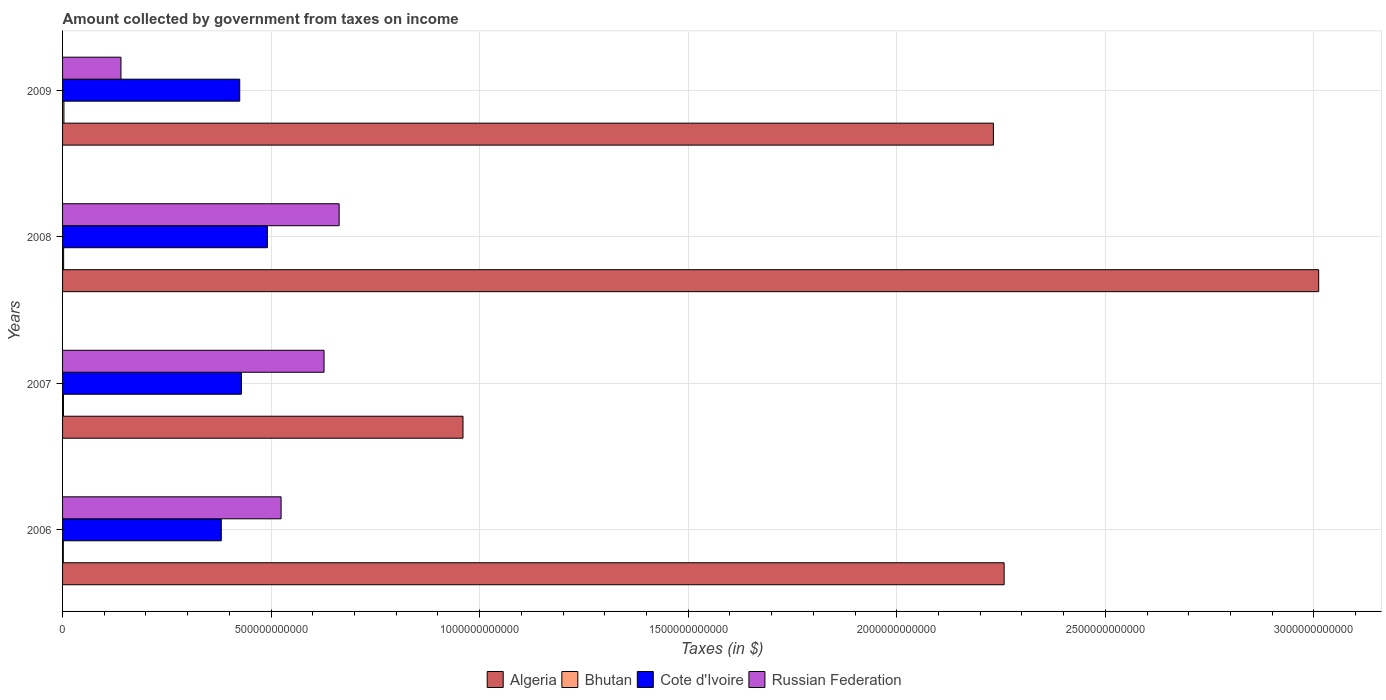Are the number of bars per tick equal to the number of legend labels?
Keep it short and to the point. Yes. How many bars are there on the 1st tick from the top?
Keep it short and to the point. 4. How many bars are there on the 4th tick from the bottom?
Your answer should be very brief. 4. What is the label of the 4th group of bars from the top?
Ensure brevity in your answer.  2006. In how many cases, is the number of bars for a given year not equal to the number of legend labels?
Give a very brief answer. 0. What is the amount collected by government from taxes on income in Bhutan in 2006?
Ensure brevity in your answer.  1.83e+09. Across all years, what is the maximum amount collected by government from taxes on income in Bhutan?
Your response must be concise. 3.28e+09. Across all years, what is the minimum amount collected by government from taxes on income in Algeria?
Provide a succinct answer. 9.60e+11. In which year was the amount collected by government from taxes on income in Bhutan maximum?
Give a very brief answer. 2009. What is the total amount collected by government from taxes on income in Cote d'Ivoire in the graph?
Provide a short and direct response. 1.73e+12. What is the difference between the amount collected by government from taxes on income in Cote d'Ivoire in 2006 and that in 2009?
Give a very brief answer. -4.42e+1. What is the difference between the amount collected by government from taxes on income in Russian Federation in 2009 and the amount collected by government from taxes on income in Bhutan in 2007?
Provide a succinct answer. 1.38e+11. What is the average amount collected by government from taxes on income in Algeria per year?
Offer a very short reply. 2.12e+12. In the year 2009, what is the difference between the amount collected by government from taxes on income in Algeria and amount collected by government from taxes on income in Cote d'Ivoire?
Offer a terse response. 1.81e+12. In how many years, is the amount collected by government from taxes on income in Russian Federation greater than 1700000000000 $?
Your answer should be compact. 0. What is the ratio of the amount collected by government from taxes on income in Algeria in 2006 to that in 2007?
Make the answer very short. 2.35. Is the difference between the amount collected by government from taxes on income in Algeria in 2006 and 2009 greater than the difference between the amount collected by government from taxes on income in Cote d'Ivoire in 2006 and 2009?
Your answer should be very brief. Yes. What is the difference between the highest and the second highest amount collected by government from taxes on income in Algeria?
Provide a succinct answer. 7.54e+11. What is the difference between the highest and the lowest amount collected by government from taxes on income in Cote d'Ivoire?
Your answer should be compact. 1.10e+11. What does the 3rd bar from the top in 2006 represents?
Provide a short and direct response. Bhutan. What does the 2nd bar from the bottom in 2009 represents?
Offer a terse response. Bhutan. Is it the case that in every year, the sum of the amount collected by government from taxes on income in Bhutan and amount collected by government from taxes on income in Russian Federation is greater than the amount collected by government from taxes on income in Algeria?
Offer a terse response. No. Are all the bars in the graph horizontal?
Your answer should be compact. Yes. What is the difference between two consecutive major ticks on the X-axis?
Offer a terse response. 5.00e+11. What is the title of the graph?
Ensure brevity in your answer.  Amount collected by government from taxes on income. Does "Channel Islands" appear as one of the legend labels in the graph?
Your answer should be very brief. No. What is the label or title of the X-axis?
Your answer should be very brief. Taxes (in $). What is the label or title of the Y-axis?
Provide a succinct answer. Years. What is the Taxes (in $) of Algeria in 2006?
Your answer should be compact. 2.26e+12. What is the Taxes (in $) in Bhutan in 2006?
Provide a short and direct response. 1.83e+09. What is the Taxes (in $) of Cote d'Ivoire in 2006?
Keep it short and to the point. 3.81e+11. What is the Taxes (in $) of Russian Federation in 2006?
Offer a very short reply. 5.24e+11. What is the Taxes (in $) of Algeria in 2007?
Keep it short and to the point. 9.60e+11. What is the Taxes (in $) in Bhutan in 2007?
Your answer should be compact. 2.11e+09. What is the Taxes (in $) of Cote d'Ivoire in 2007?
Give a very brief answer. 4.29e+11. What is the Taxes (in $) in Russian Federation in 2007?
Offer a very short reply. 6.27e+11. What is the Taxes (in $) of Algeria in 2008?
Make the answer very short. 3.01e+12. What is the Taxes (in $) in Bhutan in 2008?
Ensure brevity in your answer.  2.55e+09. What is the Taxes (in $) of Cote d'Ivoire in 2008?
Give a very brief answer. 4.91e+11. What is the Taxes (in $) of Russian Federation in 2008?
Your response must be concise. 6.63e+11. What is the Taxes (in $) in Algeria in 2009?
Offer a very short reply. 2.23e+12. What is the Taxes (in $) in Bhutan in 2009?
Give a very brief answer. 3.28e+09. What is the Taxes (in $) in Cote d'Ivoire in 2009?
Give a very brief answer. 4.25e+11. What is the Taxes (in $) in Russian Federation in 2009?
Your answer should be very brief. 1.40e+11. Across all years, what is the maximum Taxes (in $) in Algeria?
Give a very brief answer. 3.01e+12. Across all years, what is the maximum Taxes (in $) in Bhutan?
Your answer should be compact. 3.28e+09. Across all years, what is the maximum Taxes (in $) of Cote d'Ivoire?
Keep it short and to the point. 4.91e+11. Across all years, what is the maximum Taxes (in $) of Russian Federation?
Provide a succinct answer. 6.63e+11. Across all years, what is the minimum Taxes (in $) in Algeria?
Offer a very short reply. 9.60e+11. Across all years, what is the minimum Taxes (in $) of Bhutan?
Make the answer very short. 1.83e+09. Across all years, what is the minimum Taxes (in $) in Cote d'Ivoire?
Offer a terse response. 3.81e+11. Across all years, what is the minimum Taxes (in $) of Russian Federation?
Keep it short and to the point. 1.40e+11. What is the total Taxes (in $) of Algeria in the graph?
Give a very brief answer. 8.46e+12. What is the total Taxes (in $) in Bhutan in the graph?
Provide a succinct answer. 9.77e+09. What is the total Taxes (in $) in Cote d'Ivoire in the graph?
Provide a short and direct response. 1.73e+12. What is the total Taxes (in $) of Russian Federation in the graph?
Keep it short and to the point. 1.95e+12. What is the difference between the Taxes (in $) in Algeria in 2006 and that in 2007?
Keep it short and to the point. 1.30e+12. What is the difference between the Taxes (in $) in Bhutan in 2006 and that in 2007?
Your answer should be compact. -2.76e+08. What is the difference between the Taxes (in $) in Cote d'Ivoire in 2006 and that in 2007?
Provide a succinct answer. -4.83e+1. What is the difference between the Taxes (in $) in Russian Federation in 2006 and that in 2007?
Keep it short and to the point. -1.03e+11. What is the difference between the Taxes (in $) in Algeria in 2006 and that in 2008?
Provide a succinct answer. -7.54e+11. What is the difference between the Taxes (in $) of Bhutan in 2006 and that in 2008?
Your answer should be very brief. -7.14e+08. What is the difference between the Taxes (in $) of Cote d'Ivoire in 2006 and that in 2008?
Give a very brief answer. -1.10e+11. What is the difference between the Taxes (in $) of Russian Federation in 2006 and that in 2008?
Offer a very short reply. -1.39e+11. What is the difference between the Taxes (in $) in Algeria in 2006 and that in 2009?
Offer a very short reply. 2.57e+1. What is the difference between the Taxes (in $) of Bhutan in 2006 and that in 2009?
Provide a succinct answer. -1.45e+09. What is the difference between the Taxes (in $) in Cote d'Ivoire in 2006 and that in 2009?
Keep it short and to the point. -4.42e+1. What is the difference between the Taxes (in $) of Russian Federation in 2006 and that in 2009?
Ensure brevity in your answer.  3.84e+11. What is the difference between the Taxes (in $) of Algeria in 2007 and that in 2008?
Make the answer very short. -2.05e+12. What is the difference between the Taxes (in $) of Bhutan in 2007 and that in 2008?
Give a very brief answer. -4.38e+08. What is the difference between the Taxes (in $) in Cote d'Ivoire in 2007 and that in 2008?
Your answer should be compact. -6.22e+1. What is the difference between the Taxes (in $) in Russian Federation in 2007 and that in 2008?
Your response must be concise. -3.62e+1. What is the difference between the Taxes (in $) of Algeria in 2007 and that in 2009?
Provide a succinct answer. -1.27e+12. What is the difference between the Taxes (in $) in Bhutan in 2007 and that in 2009?
Provide a short and direct response. -1.17e+09. What is the difference between the Taxes (in $) in Cote d'Ivoire in 2007 and that in 2009?
Offer a terse response. 4.06e+09. What is the difference between the Taxes (in $) of Russian Federation in 2007 and that in 2009?
Your answer should be very brief. 4.87e+11. What is the difference between the Taxes (in $) of Algeria in 2008 and that in 2009?
Your answer should be compact. 7.80e+11. What is the difference between the Taxes (in $) in Bhutan in 2008 and that in 2009?
Give a very brief answer. -7.35e+08. What is the difference between the Taxes (in $) of Cote d'Ivoire in 2008 and that in 2009?
Make the answer very short. 6.63e+1. What is the difference between the Taxes (in $) of Russian Federation in 2008 and that in 2009?
Ensure brevity in your answer.  5.23e+11. What is the difference between the Taxes (in $) of Algeria in 2006 and the Taxes (in $) of Bhutan in 2007?
Provide a succinct answer. 2.26e+12. What is the difference between the Taxes (in $) in Algeria in 2006 and the Taxes (in $) in Cote d'Ivoire in 2007?
Offer a very short reply. 1.83e+12. What is the difference between the Taxes (in $) in Algeria in 2006 and the Taxes (in $) in Russian Federation in 2007?
Offer a terse response. 1.63e+12. What is the difference between the Taxes (in $) in Bhutan in 2006 and the Taxes (in $) in Cote d'Ivoire in 2007?
Ensure brevity in your answer.  -4.27e+11. What is the difference between the Taxes (in $) in Bhutan in 2006 and the Taxes (in $) in Russian Federation in 2007?
Provide a short and direct response. -6.25e+11. What is the difference between the Taxes (in $) in Cote d'Ivoire in 2006 and the Taxes (in $) in Russian Federation in 2007?
Keep it short and to the point. -2.46e+11. What is the difference between the Taxes (in $) in Algeria in 2006 and the Taxes (in $) in Bhutan in 2008?
Give a very brief answer. 2.25e+12. What is the difference between the Taxes (in $) in Algeria in 2006 and the Taxes (in $) in Cote d'Ivoire in 2008?
Ensure brevity in your answer.  1.77e+12. What is the difference between the Taxes (in $) of Algeria in 2006 and the Taxes (in $) of Russian Federation in 2008?
Keep it short and to the point. 1.59e+12. What is the difference between the Taxes (in $) in Bhutan in 2006 and the Taxes (in $) in Cote d'Ivoire in 2008?
Provide a succinct answer. -4.89e+11. What is the difference between the Taxes (in $) in Bhutan in 2006 and the Taxes (in $) in Russian Federation in 2008?
Your answer should be compact. -6.61e+11. What is the difference between the Taxes (in $) in Cote d'Ivoire in 2006 and the Taxes (in $) in Russian Federation in 2008?
Give a very brief answer. -2.83e+11. What is the difference between the Taxes (in $) of Algeria in 2006 and the Taxes (in $) of Bhutan in 2009?
Your answer should be compact. 2.25e+12. What is the difference between the Taxes (in $) in Algeria in 2006 and the Taxes (in $) in Cote d'Ivoire in 2009?
Provide a short and direct response. 1.83e+12. What is the difference between the Taxes (in $) of Algeria in 2006 and the Taxes (in $) of Russian Federation in 2009?
Offer a terse response. 2.12e+12. What is the difference between the Taxes (in $) of Bhutan in 2006 and the Taxes (in $) of Cote d'Ivoire in 2009?
Your answer should be compact. -4.23e+11. What is the difference between the Taxes (in $) in Bhutan in 2006 and the Taxes (in $) in Russian Federation in 2009?
Your answer should be compact. -1.38e+11. What is the difference between the Taxes (in $) of Cote d'Ivoire in 2006 and the Taxes (in $) of Russian Federation in 2009?
Provide a succinct answer. 2.41e+11. What is the difference between the Taxes (in $) of Algeria in 2007 and the Taxes (in $) of Bhutan in 2008?
Your answer should be very brief. 9.57e+11. What is the difference between the Taxes (in $) of Algeria in 2007 and the Taxes (in $) of Cote d'Ivoire in 2008?
Provide a short and direct response. 4.69e+11. What is the difference between the Taxes (in $) in Algeria in 2007 and the Taxes (in $) in Russian Federation in 2008?
Make the answer very short. 2.97e+11. What is the difference between the Taxes (in $) in Bhutan in 2007 and the Taxes (in $) in Cote d'Ivoire in 2008?
Your response must be concise. -4.89e+11. What is the difference between the Taxes (in $) of Bhutan in 2007 and the Taxes (in $) of Russian Federation in 2008?
Provide a succinct answer. -6.61e+11. What is the difference between the Taxes (in $) of Cote d'Ivoire in 2007 and the Taxes (in $) of Russian Federation in 2008?
Your answer should be compact. -2.34e+11. What is the difference between the Taxes (in $) in Algeria in 2007 and the Taxes (in $) in Bhutan in 2009?
Your answer should be very brief. 9.57e+11. What is the difference between the Taxes (in $) of Algeria in 2007 and the Taxes (in $) of Cote d'Ivoire in 2009?
Offer a very short reply. 5.35e+11. What is the difference between the Taxes (in $) in Algeria in 2007 and the Taxes (in $) in Russian Federation in 2009?
Give a very brief answer. 8.20e+11. What is the difference between the Taxes (in $) of Bhutan in 2007 and the Taxes (in $) of Cote d'Ivoire in 2009?
Offer a very short reply. -4.23e+11. What is the difference between the Taxes (in $) of Bhutan in 2007 and the Taxes (in $) of Russian Federation in 2009?
Keep it short and to the point. -1.38e+11. What is the difference between the Taxes (in $) of Cote d'Ivoire in 2007 and the Taxes (in $) of Russian Federation in 2009?
Your answer should be very brief. 2.89e+11. What is the difference between the Taxes (in $) in Algeria in 2008 and the Taxes (in $) in Bhutan in 2009?
Make the answer very short. 3.01e+12. What is the difference between the Taxes (in $) of Algeria in 2008 and the Taxes (in $) of Cote d'Ivoire in 2009?
Offer a terse response. 2.59e+12. What is the difference between the Taxes (in $) of Algeria in 2008 and the Taxes (in $) of Russian Federation in 2009?
Provide a succinct answer. 2.87e+12. What is the difference between the Taxes (in $) of Bhutan in 2008 and the Taxes (in $) of Cote d'Ivoire in 2009?
Give a very brief answer. -4.22e+11. What is the difference between the Taxes (in $) of Bhutan in 2008 and the Taxes (in $) of Russian Federation in 2009?
Give a very brief answer. -1.37e+11. What is the difference between the Taxes (in $) in Cote d'Ivoire in 2008 and the Taxes (in $) in Russian Federation in 2009?
Your answer should be very brief. 3.51e+11. What is the average Taxes (in $) of Algeria per year?
Ensure brevity in your answer.  2.12e+12. What is the average Taxes (in $) in Bhutan per year?
Ensure brevity in your answer.  2.44e+09. What is the average Taxes (in $) in Cote d'Ivoire per year?
Give a very brief answer. 4.31e+11. What is the average Taxes (in $) in Russian Federation per year?
Provide a succinct answer. 4.88e+11. In the year 2006, what is the difference between the Taxes (in $) in Algeria and Taxes (in $) in Bhutan?
Offer a terse response. 2.26e+12. In the year 2006, what is the difference between the Taxes (in $) of Algeria and Taxes (in $) of Cote d'Ivoire?
Your answer should be compact. 1.88e+12. In the year 2006, what is the difference between the Taxes (in $) in Algeria and Taxes (in $) in Russian Federation?
Make the answer very short. 1.73e+12. In the year 2006, what is the difference between the Taxes (in $) of Bhutan and Taxes (in $) of Cote d'Ivoire?
Your answer should be compact. -3.79e+11. In the year 2006, what is the difference between the Taxes (in $) of Bhutan and Taxes (in $) of Russian Federation?
Your answer should be compact. -5.22e+11. In the year 2006, what is the difference between the Taxes (in $) in Cote d'Ivoire and Taxes (in $) in Russian Federation?
Offer a terse response. -1.43e+11. In the year 2007, what is the difference between the Taxes (in $) in Algeria and Taxes (in $) in Bhutan?
Offer a very short reply. 9.58e+11. In the year 2007, what is the difference between the Taxes (in $) in Algeria and Taxes (in $) in Cote d'Ivoire?
Ensure brevity in your answer.  5.31e+11. In the year 2007, what is the difference between the Taxes (in $) of Algeria and Taxes (in $) of Russian Federation?
Provide a short and direct response. 3.33e+11. In the year 2007, what is the difference between the Taxes (in $) in Bhutan and Taxes (in $) in Cote d'Ivoire?
Provide a succinct answer. -4.27e+11. In the year 2007, what is the difference between the Taxes (in $) of Bhutan and Taxes (in $) of Russian Federation?
Your answer should be compact. -6.25e+11. In the year 2007, what is the difference between the Taxes (in $) in Cote d'Ivoire and Taxes (in $) in Russian Federation?
Your answer should be compact. -1.98e+11. In the year 2008, what is the difference between the Taxes (in $) of Algeria and Taxes (in $) of Bhutan?
Offer a terse response. 3.01e+12. In the year 2008, what is the difference between the Taxes (in $) of Algeria and Taxes (in $) of Cote d'Ivoire?
Offer a very short reply. 2.52e+12. In the year 2008, what is the difference between the Taxes (in $) in Algeria and Taxes (in $) in Russian Federation?
Your response must be concise. 2.35e+12. In the year 2008, what is the difference between the Taxes (in $) of Bhutan and Taxes (in $) of Cote d'Ivoire?
Keep it short and to the point. -4.88e+11. In the year 2008, what is the difference between the Taxes (in $) of Bhutan and Taxes (in $) of Russian Federation?
Ensure brevity in your answer.  -6.61e+11. In the year 2008, what is the difference between the Taxes (in $) in Cote d'Ivoire and Taxes (in $) in Russian Federation?
Keep it short and to the point. -1.72e+11. In the year 2009, what is the difference between the Taxes (in $) in Algeria and Taxes (in $) in Bhutan?
Offer a very short reply. 2.23e+12. In the year 2009, what is the difference between the Taxes (in $) of Algeria and Taxes (in $) of Cote d'Ivoire?
Give a very brief answer. 1.81e+12. In the year 2009, what is the difference between the Taxes (in $) in Algeria and Taxes (in $) in Russian Federation?
Provide a short and direct response. 2.09e+12. In the year 2009, what is the difference between the Taxes (in $) of Bhutan and Taxes (in $) of Cote d'Ivoire?
Your answer should be compact. -4.21e+11. In the year 2009, what is the difference between the Taxes (in $) of Bhutan and Taxes (in $) of Russian Federation?
Provide a short and direct response. -1.37e+11. In the year 2009, what is the difference between the Taxes (in $) in Cote d'Ivoire and Taxes (in $) in Russian Federation?
Offer a terse response. 2.85e+11. What is the ratio of the Taxes (in $) of Algeria in 2006 to that in 2007?
Ensure brevity in your answer.  2.35. What is the ratio of the Taxes (in $) in Bhutan in 2006 to that in 2007?
Your answer should be compact. 0.87. What is the ratio of the Taxes (in $) in Cote d'Ivoire in 2006 to that in 2007?
Provide a short and direct response. 0.89. What is the ratio of the Taxes (in $) of Russian Federation in 2006 to that in 2007?
Your answer should be very brief. 0.84. What is the ratio of the Taxes (in $) in Algeria in 2006 to that in 2008?
Keep it short and to the point. 0.75. What is the ratio of the Taxes (in $) in Bhutan in 2006 to that in 2008?
Offer a very short reply. 0.72. What is the ratio of the Taxes (in $) of Cote d'Ivoire in 2006 to that in 2008?
Offer a very short reply. 0.78. What is the ratio of the Taxes (in $) in Russian Federation in 2006 to that in 2008?
Provide a succinct answer. 0.79. What is the ratio of the Taxes (in $) in Algeria in 2006 to that in 2009?
Make the answer very short. 1.01. What is the ratio of the Taxes (in $) in Bhutan in 2006 to that in 2009?
Make the answer very short. 0.56. What is the ratio of the Taxes (in $) of Cote d'Ivoire in 2006 to that in 2009?
Offer a very short reply. 0.9. What is the ratio of the Taxes (in $) of Russian Federation in 2006 to that in 2009?
Provide a succinct answer. 3.74. What is the ratio of the Taxes (in $) of Algeria in 2007 to that in 2008?
Keep it short and to the point. 0.32. What is the ratio of the Taxes (in $) in Bhutan in 2007 to that in 2008?
Keep it short and to the point. 0.83. What is the ratio of the Taxes (in $) of Cote d'Ivoire in 2007 to that in 2008?
Your answer should be very brief. 0.87. What is the ratio of the Taxes (in $) in Russian Federation in 2007 to that in 2008?
Your response must be concise. 0.95. What is the ratio of the Taxes (in $) of Algeria in 2007 to that in 2009?
Provide a succinct answer. 0.43. What is the ratio of the Taxes (in $) of Bhutan in 2007 to that in 2009?
Ensure brevity in your answer.  0.64. What is the ratio of the Taxes (in $) of Cote d'Ivoire in 2007 to that in 2009?
Your answer should be very brief. 1.01. What is the ratio of the Taxes (in $) of Russian Federation in 2007 to that in 2009?
Offer a very short reply. 4.48. What is the ratio of the Taxes (in $) of Algeria in 2008 to that in 2009?
Ensure brevity in your answer.  1.35. What is the ratio of the Taxes (in $) in Bhutan in 2008 to that in 2009?
Your answer should be compact. 0.78. What is the ratio of the Taxes (in $) in Cote d'Ivoire in 2008 to that in 2009?
Your answer should be very brief. 1.16. What is the ratio of the Taxes (in $) of Russian Federation in 2008 to that in 2009?
Your answer should be very brief. 4.74. What is the difference between the highest and the second highest Taxes (in $) of Algeria?
Your answer should be compact. 7.54e+11. What is the difference between the highest and the second highest Taxes (in $) in Bhutan?
Make the answer very short. 7.35e+08. What is the difference between the highest and the second highest Taxes (in $) in Cote d'Ivoire?
Provide a short and direct response. 6.22e+1. What is the difference between the highest and the second highest Taxes (in $) of Russian Federation?
Keep it short and to the point. 3.62e+1. What is the difference between the highest and the lowest Taxes (in $) of Algeria?
Provide a succinct answer. 2.05e+12. What is the difference between the highest and the lowest Taxes (in $) in Bhutan?
Give a very brief answer. 1.45e+09. What is the difference between the highest and the lowest Taxes (in $) of Cote d'Ivoire?
Offer a very short reply. 1.10e+11. What is the difference between the highest and the lowest Taxes (in $) of Russian Federation?
Keep it short and to the point. 5.23e+11. 